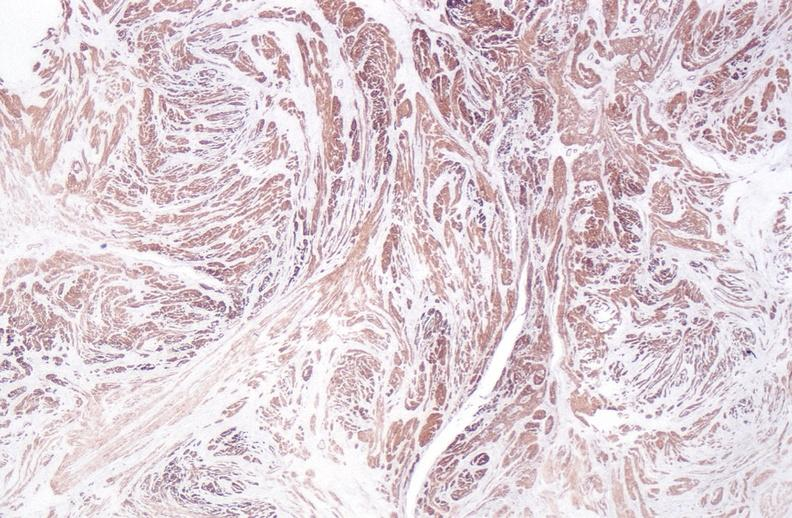what is present?
Answer the question using a single word or phrase. Female reproductive 